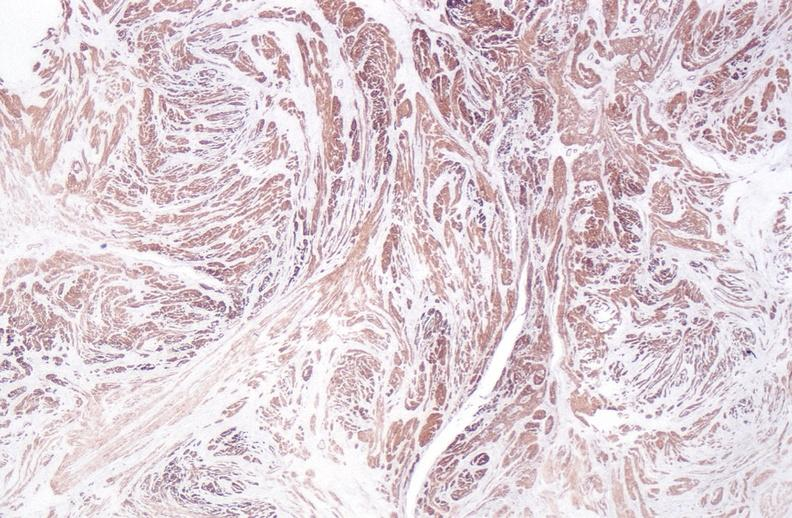what is present?
Answer the question using a single word or phrase. Female reproductive 